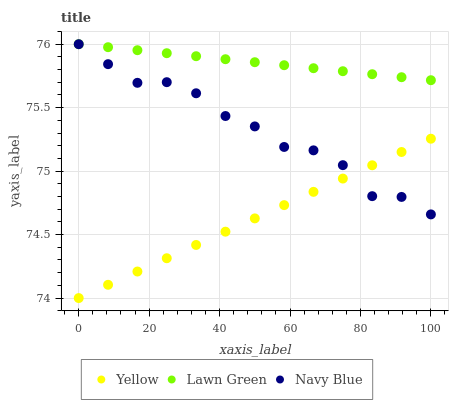Does Yellow have the minimum area under the curve?
Answer yes or no. Yes. Does Lawn Green have the maximum area under the curve?
Answer yes or no. Yes. Does Navy Blue have the minimum area under the curve?
Answer yes or no. No. Does Navy Blue have the maximum area under the curve?
Answer yes or no. No. Is Lawn Green the smoothest?
Answer yes or no. Yes. Is Navy Blue the roughest?
Answer yes or no. Yes. Is Yellow the smoothest?
Answer yes or no. No. Is Yellow the roughest?
Answer yes or no. No. Does Yellow have the lowest value?
Answer yes or no. Yes. Does Navy Blue have the lowest value?
Answer yes or no. No. Does Navy Blue have the highest value?
Answer yes or no. Yes. Does Yellow have the highest value?
Answer yes or no. No. Is Yellow less than Lawn Green?
Answer yes or no. Yes. Is Lawn Green greater than Yellow?
Answer yes or no. Yes. Does Navy Blue intersect Lawn Green?
Answer yes or no. Yes. Is Navy Blue less than Lawn Green?
Answer yes or no. No. Is Navy Blue greater than Lawn Green?
Answer yes or no. No. Does Yellow intersect Lawn Green?
Answer yes or no. No. 